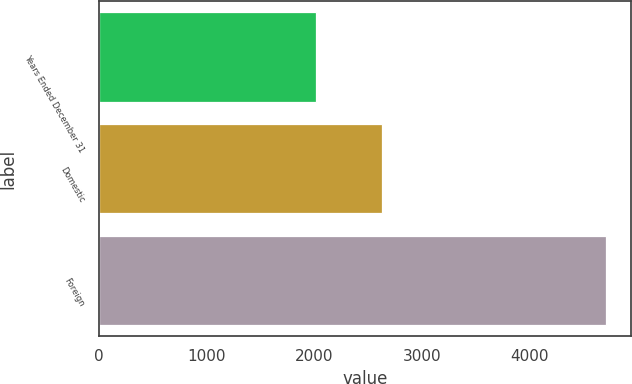Convert chart. <chart><loc_0><loc_0><loc_500><loc_500><bar_chart><fcel>Years Ended December 31<fcel>Domestic<fcel>Foreign<nl><fcel>2011<fcel>2626<fcel>4708<nl></chart> 